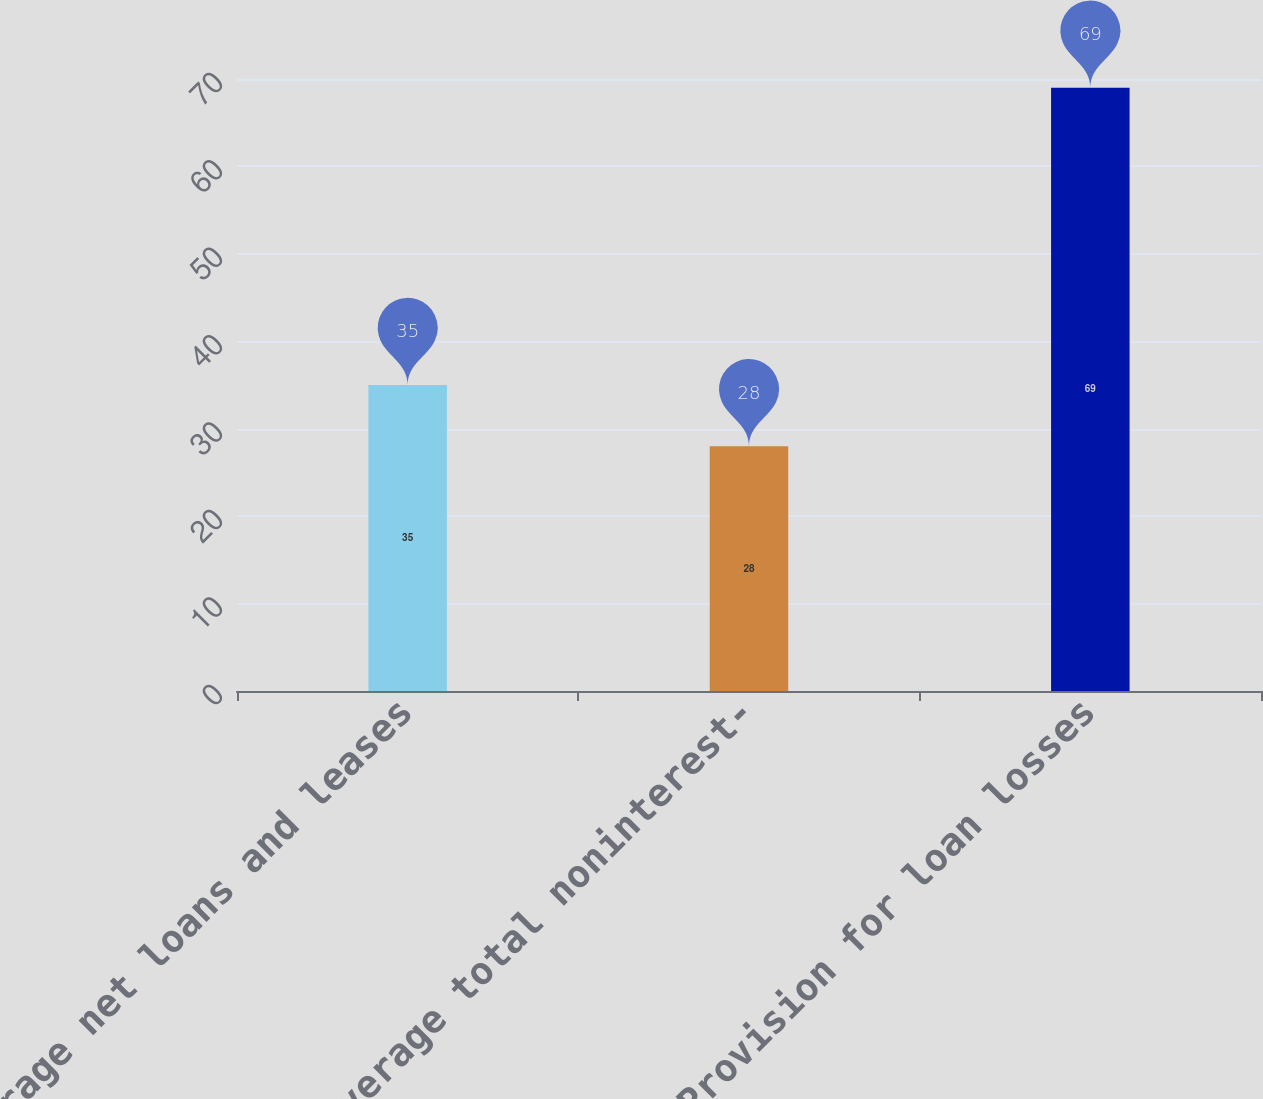Convert chart. <chart><loc_0><loc_0><loc_500><loc_500><bar_chart><fcel>Average net loans and leases<fcel>Average total noninterest-<fcel>Provision for loan losses<nl><fcel>35<fcel>28<fcel>69<nl></chart> 